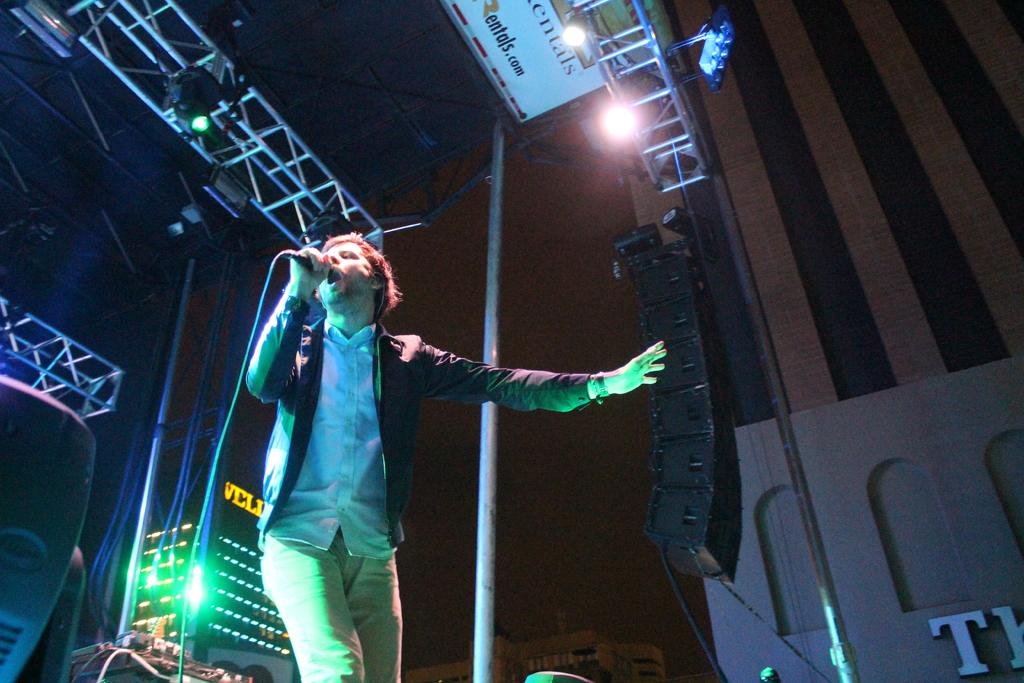What is the man in the image holding? The man is holding a mic in the image. What other objects can be seen in the image besides the man? There are rods and poles, lights, and speakers in the image. What type of sheet is being used to support the duck in the image? There is no sheet or duck present in the image. What kind of beam is holding up the lights in the image? The image does not show the specific type of beam holding up the lights, only that there are lights present. 